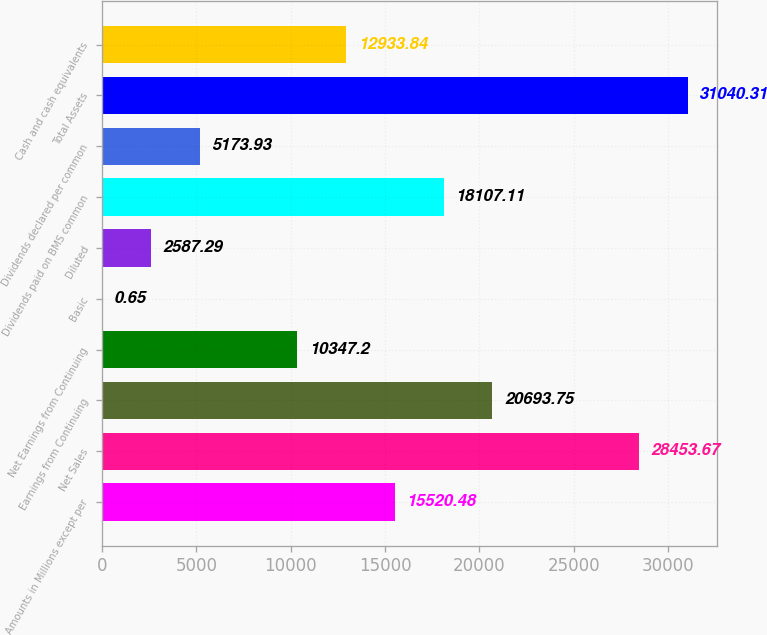<chart> <loc_0><loc_0><loc_500><loc_500><bar_chart><fcel>Amounts in Millions except per<fcel>Net Sales<fcel>Earnings from Continuing<fcel>Net Earnings from Continuing<fcel>Basic<fcel>Diluted<fcel>Dividends paid on BMS common<fcel>Dividends declared per common<fcel>Total Assets<fcel>Cash and cash equivalents<nl><fcel>15520.5<fcel>28453.7<fcel>20693.8<fcel>10347.2<fcel>0.65<fcel>2587.29<fcel>18107.1<fcel>5173.93<fcel>31040.3<fcel>12933.8<nl></chart> 